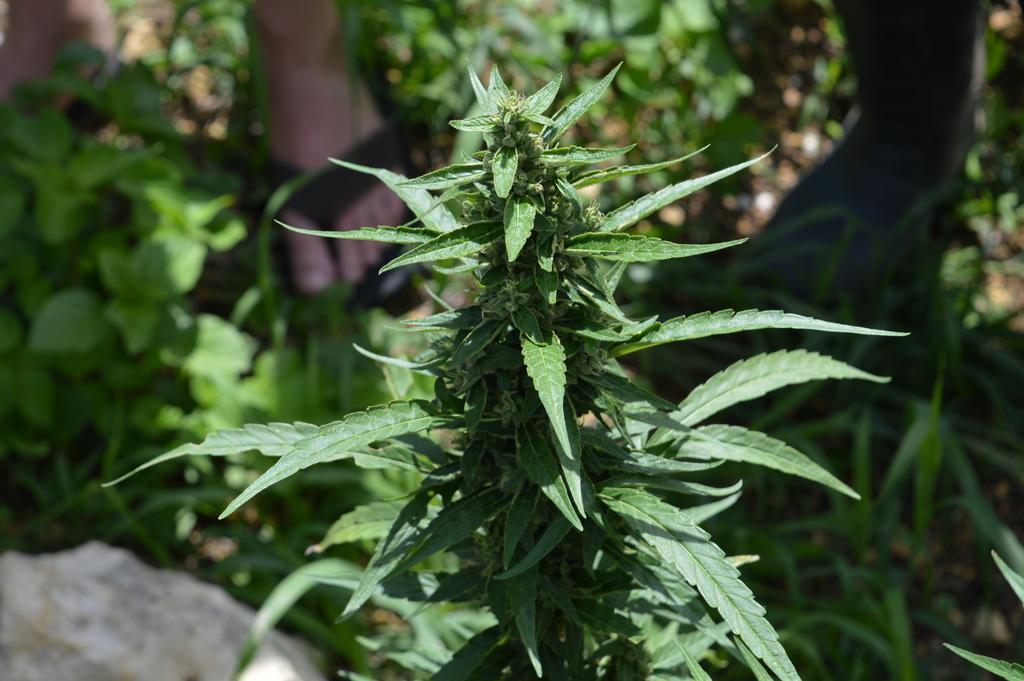Can you describe this image briefly? Here we can see green leaves. Background it is blur. We can see a rock, leaves and person legs. 